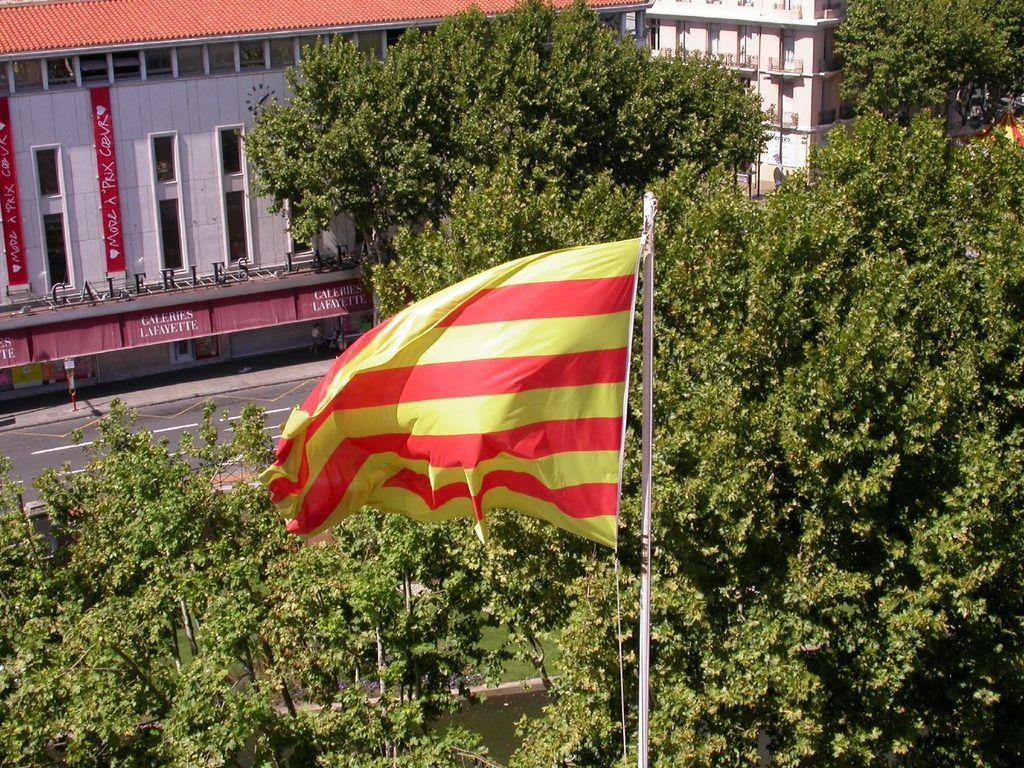What can be seen flying or waving in the image? There is a flag in the image. What natural element is visible in the image? There is water visible in the image. What type of vegetation is present in the image? There are trees in the image. What man-made feature is in the center of the image? There is a road in the center of the image. What structures can be seen in the distance in the image? There are buildings in the background of the image. What verse can be heard recited by the nose in the image? There is no nose or verse present in the image. What type of observation can be made about the flag in the image? The question is not absurd, as it is related to the flag in the image. An appropriate answer could be: The flag appears to be waving in the wind, indicating that there might be a breeze in the area. 